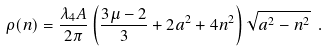Convert formula to latex. <formula><loc_0><loc_0><loc_500><loc_500>\rho ( n ) = \frac { \lambda _ { 4 } A } { 2 \pi } \left ( \frac { 3 \mu - 2 } { 3 } + 2 a ^ { 2 } + 4 n ^ { 2 } \right ) \sqrt { a ^ { 2 } - n ^ { 2 } } \ .</formula> 